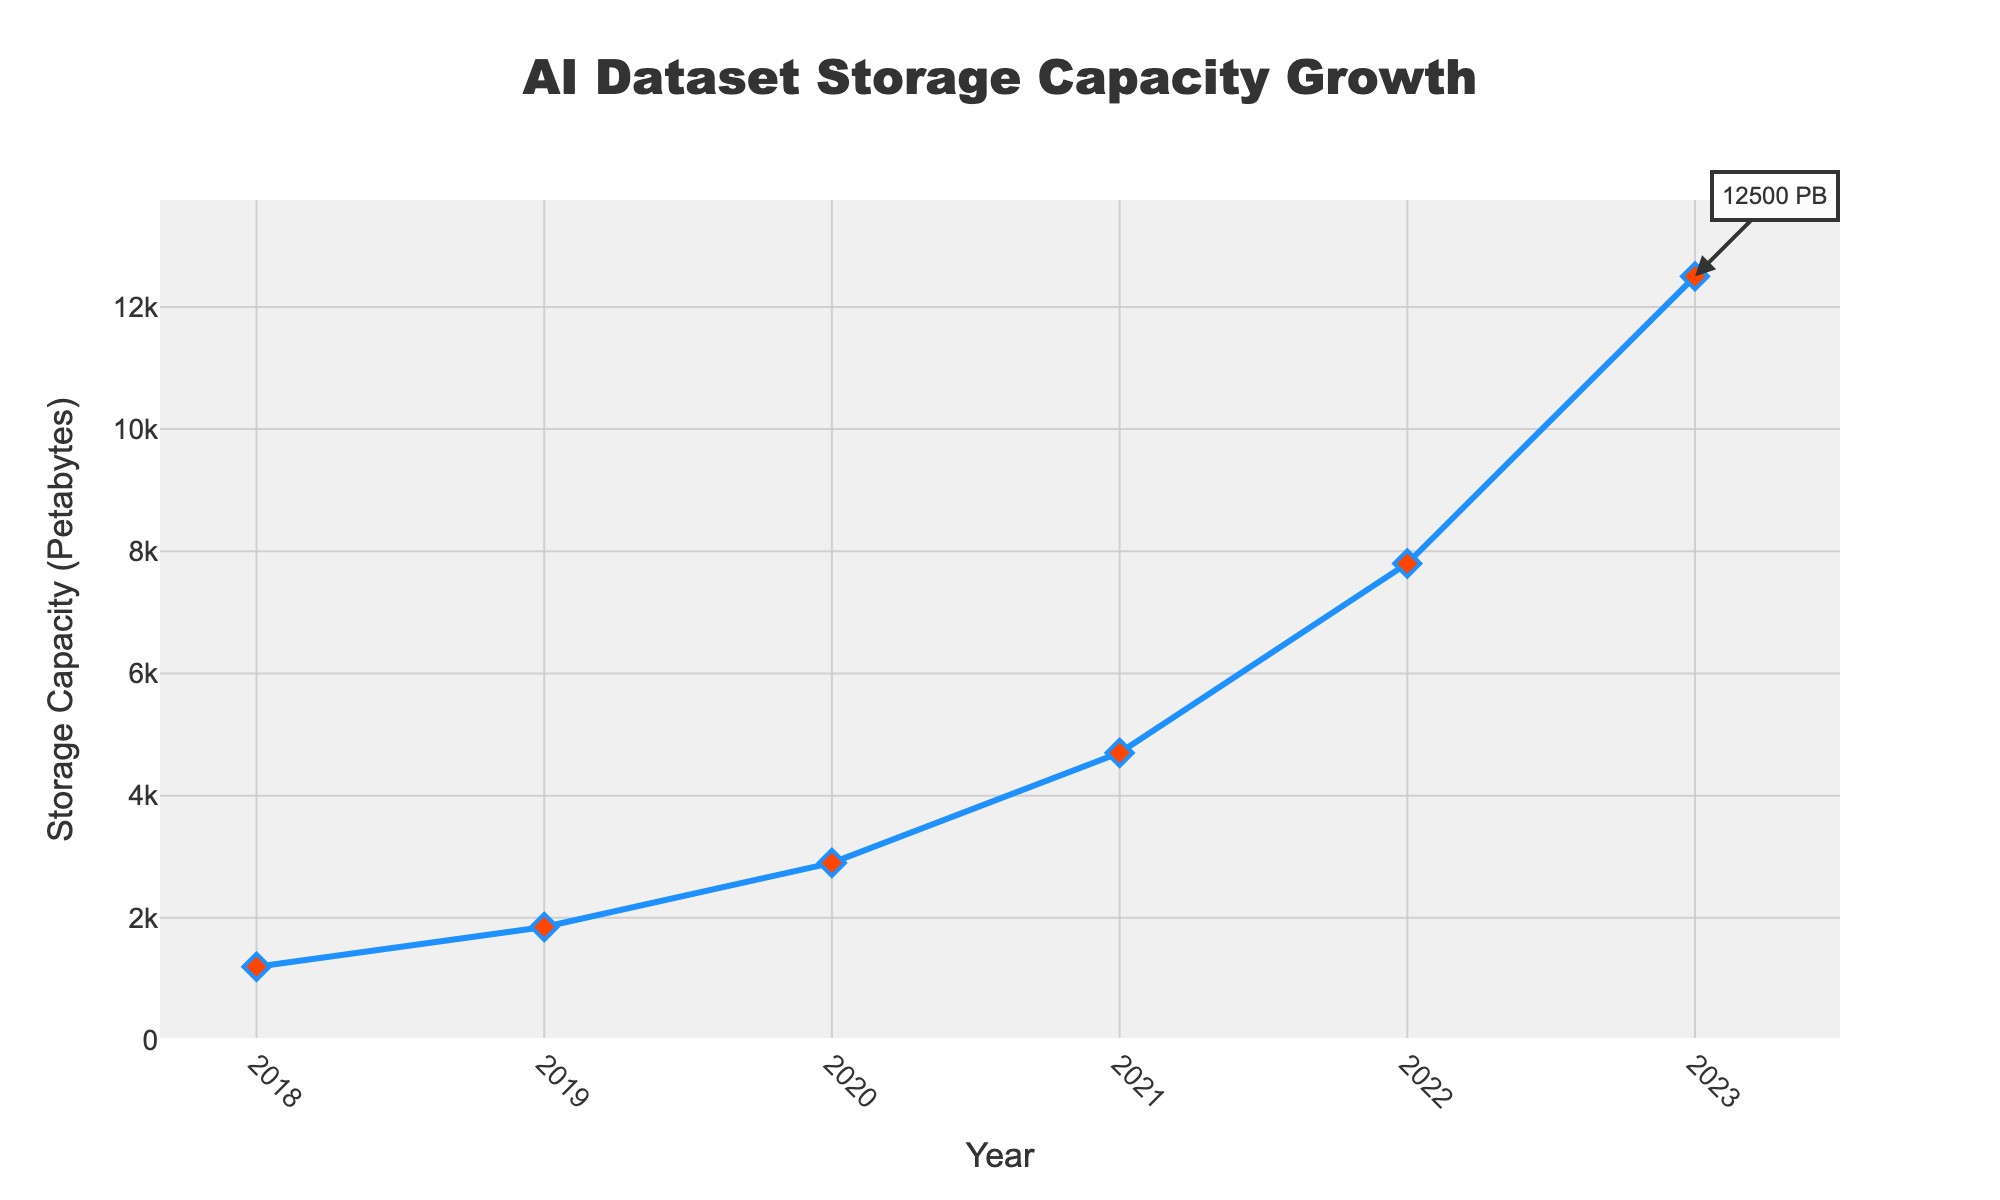What is the trend of storage capacity growth over the past 5 years? The line chart shows a consistent increase in storage capacity, indicating the growth is exponential from 2018 to 2023. The values start at 1200 Petabytes in 2018 and increase to 12500 Petabytes by 2023.
Answer: Exponential Increase In which year did the storage capacity experience the largest increase compared to the previous year? To find the year with the largest increase, calculate the difference between consecutive years. The differences are 650 (2019-2018), 1050 (2020-2019), 1800 (2021-2020), 3100 (2022-2021), 4700 (2023-2022). The largest increase is between 2022 and 2023.
Answer: 2023 What was the average storage capacity over the 5 years? Calculate the sum of the storage capacities for each year and divide by the number of years: (1200 + 1850 + 2900 + 4700 + 7800 + 12500) / 6 = 30950 / 6 ≈ 5158.33 Petabytes.
Answer: 5158.33 Petabytes How does the storage capacity in 2019 compare to 2018? The storage capacity in 2019 is 1850 Petabytes, while in 2018 it is 1200 Petabytes. There is an increase of 650 Petabytes from 2018 to 2019.
Answer: 650 Petabytes increase Which year had the smallest growth in storage capacity compared to the previous year? Calculate the differences between consecutive years: 650 (2019-2018), 1050 (2020-2019), 1800 (2021-2020), 3100 (2022-2021), 4700 (2023-2022). The smallest increase is 650 Petabytes, occurring between 2018 and 2019.
Answer: 2019 What is the ratio of storage capacity in 2023 compared to 2018? Divide the storage capacity in 2023 by the storage capacity in 2018: 12500 Petabytes (2023) / 1200 Petabytes (2018) ≈ 10.42.
Answer: 10.42 What visual element marks the peak storage capacity on the chart? The peak storage capacity is marked by a red diamond at the end of the line in 2023, annotated with "12500 PB".
Answer: Red diamond How much did the storage capacity increase from 2020 to 2022? To find the increase, subtract the 2020 value from the 2022 value: 7800 Petabytes (2022) - 2900 Petabytes (2020) = 4900 Petabytes.
Answer: 4900 Petabytes 